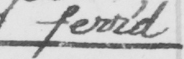Please transcribe the handwritten text in this image. ferr ' d 